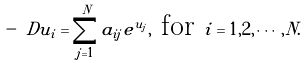Convert formula to latex. <formula><loc_0><loc_0><loc_500><loc_500>- \ D u _ { i } = \sum ^ { N } _ { j = 1 } a _ { i j } e ^ { u _ { j } } , \text { for } i = 1 , 2 , \cdots , N .</formula> 